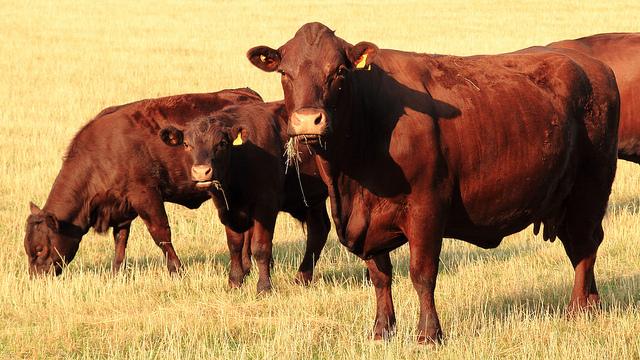What is the color of the cows?
Be succinct. Brown. What are the yellow tags on the cows for?
Short answer required. Identification. How many cows are eating?
Short answer required. 3. 